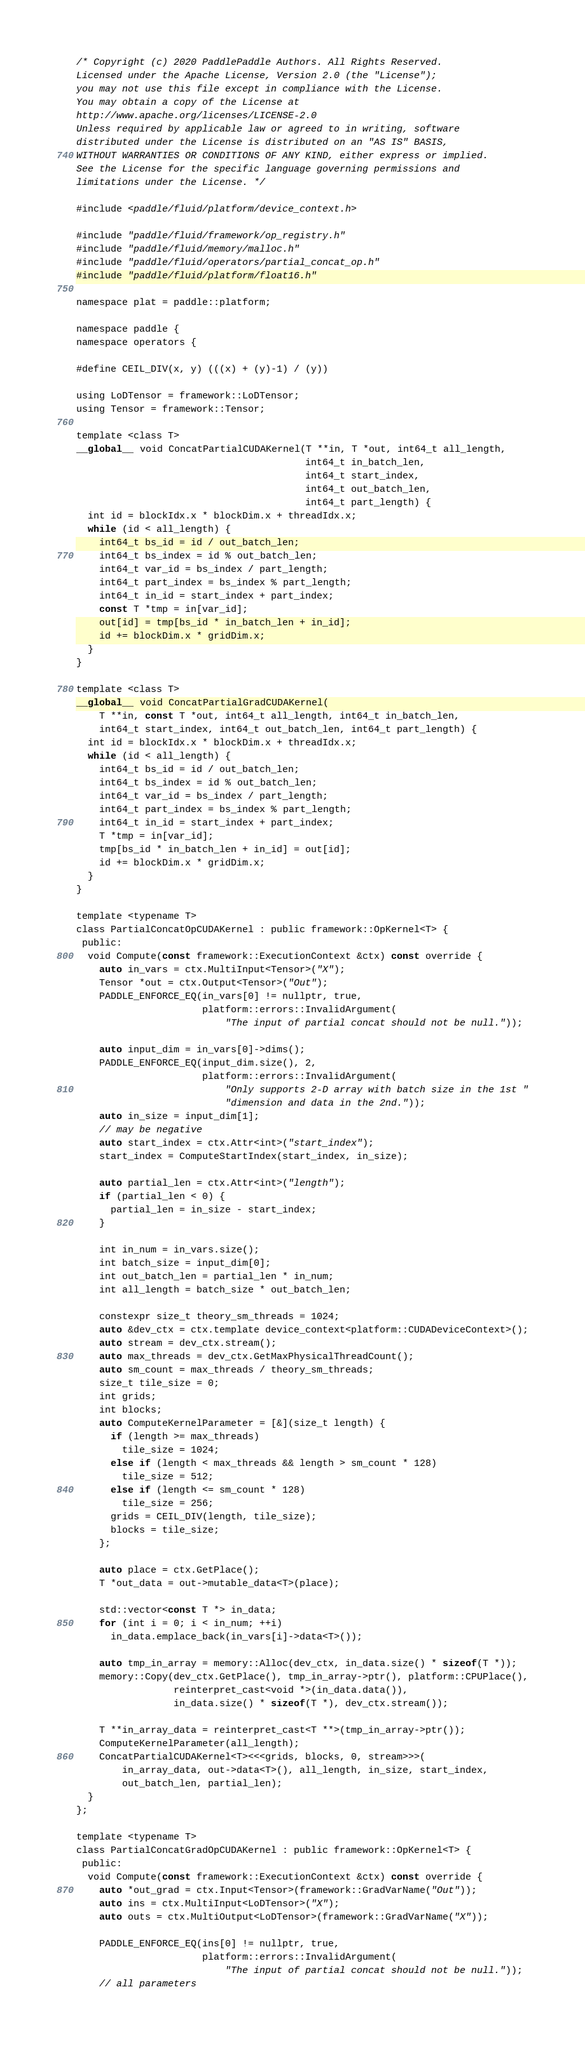Convert code to text. <code><loc_0><loc_0><loc_500><loc_500><_Cuda_>/* Copyright (c) 2020 PaddlePaddle Authors. All Rights Reserved.
Licensed under the Apache License, Version 2.0 (the "License");
you may not use this file except in compliance with the License.
You may obtain a copy of the License at
http://www.apache.org/licenses/LICENSE-2.0
Unless required by applicable law or agreed to in writing, software
distributed under the License is distributed on an "AS IS" BASIS,
WITHOUT WARRANTIES OR CONDITIONS OF ANY KIND, either express or implied.
See the License for the specific language governing permissions and
limitations under the License. */

#include <paddle/fluid/platform/device_context.h>

#include "paddle/fluid/framework/op_registry.h"
#include "paddle/fluid/memory/malloc.h"
#include "paddle/fluid/operators/partial_concat_op.h"
#include "paddle/fluid/platform/float16.h"

namespace plat = paddle::platform;

namespace paddle {
namespace operators {

#define CEIL_DIV(x, y) (((x) + (y)-1) / (y))

using LoDTensor = framework::LoDTensor;
using Tensor = framework::Tensor;

template <class T>
__global__ void ConcatPartialCUDAKernel(T **in, T *out, int64_t all_length,
                                        int64_t in_batch_len,
                                        int64_t start_index,
                                        int64_t out_batch_len,
                                        int64_t part_length) {
  int id = blockIdx.x * blockDim.x + threadIdx.x;
  while (id < all_length) {
    int64_t bs_id = id / out_batch_len;
    int64_t bs_index = id % out_batch_len;
    int64_t var_id = bs_index / part_length;
    int64_t part_index = bs_index % part_length;
    int64_t in_id = start_index + part_index;
    const T *tmp = in[var_id];
    out[id] = tmp[bs_id * in_batch_len + in_id];
    id += blockDim.x * gridDim.x;
  }
}

template <class T>
__global__ void ConcatPartialGradCUDAKernel(
    T **in, const T *out, int64_t all_length, int64_t in_batch_len,
    int64_t start_index, int64_t out_batch_len, int64_t part_length) {
  int id = blockIdx.x * blockDim.x + threadIdx.x;
  while (id < all_length) {
    int64_t bs_id = id / out_batch_len;
    int64_t bs_index = id % out_batch_len;
    int64_t var_id = bs_index / part_length;
    int64_t part_index = bs_index % part_length;
    int64_t in_id = start_index + part_index;
    T *tmp = in[var_id];
    tmp[bs_id * in_batch_len + in_id] = out[id];
    id += blockDim.x * gridDim.x;
  }
}

template <typename T>
class PartialConcatOpCUDAKernel : public framework::OpKernel<T> {
 public:
  void Compute(const framework::ExecutionContext &ctx) const override {
    auto in_vars = ctx.MultiInput<Tensor>("X");
    Tensor *out = ctx.Output<Tensor>("Out");
    PADDLE_ENFORCE_EQ(in_vars[0] != nullptr, true,
                      platform::errors::InvalidArgument(
                          "The input of partial concat should not be null."));

    auto input_dim = in_vars[0]->dims();
    PADDLE_ENFORCE_EQ(input_dim.size(), 2,
                      platform::errors::InvalidArgument(
                          "Only supports 2-D array with batch size in the 1st "
                          "dimension and data in the 2nd."));
    auto in_size = input_dim[1];
    // may be negative
    auto start_index = ctx.Attr<int>("start_index");
    start_index = ComputeStartIndex(start_index, in_size);

    auto partial_len = ctx.Attr<int>("length");
    if (partial_len < 0) {
      partial_len = in_size - start_index;
    }

    int in_num = in_vars.size();
    int batch_size = input_dim[0];
    int out_batch_len = partial_len * in_num;
    int all_length = batch_size * out_batch_len;

    constexpr size_t theory_sm_threads = 1024;
    auto &dev_ctx = ctx.template device_context<platform::CUDADeviceContext>();
    auto stream = dev_ctx.stream();
    auto max_threads = dev_ctx.GetMaxPhysicalThreadCount();
    auto sm_count = max_threads / theory_sm_threads;
    size_t tile_size = 0;
    int grids;
    int blocks;
    auto ComputeKernelParameter = [&](size_t length) {
      if (length >= max_threads)
        tile_size = 1024;
      else if (length < max_threads && length > sm_count * 128)
        tile_size = 512;
      else if (length <= sm_count * 128)
        tile_size = 256;
      grids = CEIL_DIV(length, tile_size);
      blocks = tile_size;
    };

    auto place = ctx.GetPlace();
    T *out_data = out->mutable_data<T>(place);

    std::vector<const T *> in_data;
    for (int i = 0; i < in_num; ++i)
      in_data.emplace_back(in_vars[i]->data<T>());

    auto tmp_in_array = memory::Alloc(dev_ctx, in_data.size() * sizeof(T *));
    memory::Copy(dev_ctx.GetPlace(), tmp_in_array->ptr(), platform::CPUPlace(),
                 reinterpret_cast<void *>(in_data.data()),
                 in_data.size() * sizeof(T *), dev_ctx.stream());

    T **in_array_data = reinterpret_cast<T **>(tmp_in_array->ptr());
    ComputeKernelParameter(all_length);
    ConcatPartialCUDAKernel<T><<<grids, blocks, 0, stream>>>(
        in_array_data, out->data<T>(), all_length, in_size, start_index,
        out_batch_len, partial_len);
  }
};

template <typename T>
class PartialConcatGradOpCUDAKernel : public framework::OpKernel<T> {
 public:
  void Compute(const framework::ExecutionContext &ctx) const override {
    auto *out_grad = ctx.Input<Tensor>(framework::GradVarName("Out"));
    auto ins = ctx.MultiInput<LoDTensor>("X");
    auto outs = ctx.MultiOutput<LoDTensor>(framework::GradVarName("X"));

    PADDLE_ENFORCE_EQ(ins[0] != nullptr, true,
                      platform::errors::InvalidArgument(
                          "The input of partial concat should not be null."));
    // all parameters</code> 